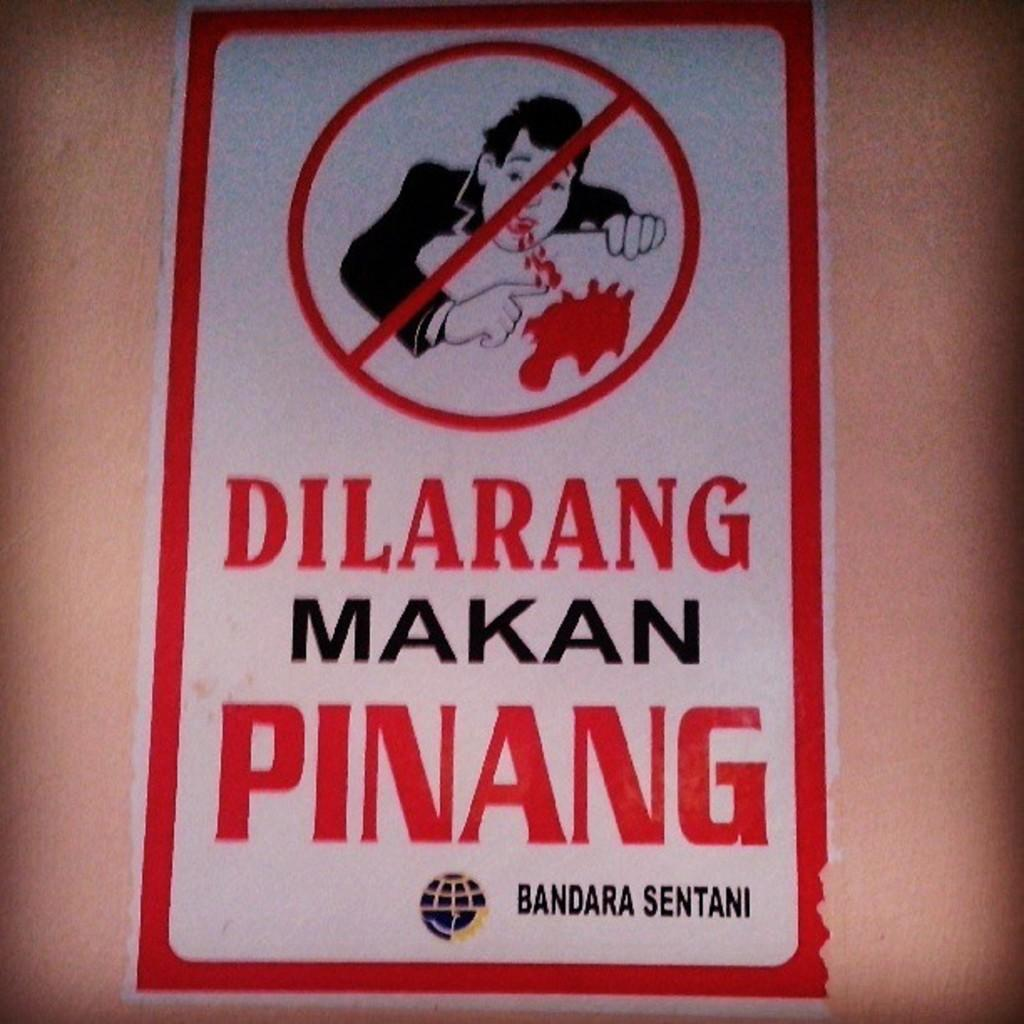<image>
Offer a succinct explanation of the picture presented. Dilarang Makan Pinang is written on this warning sign. 